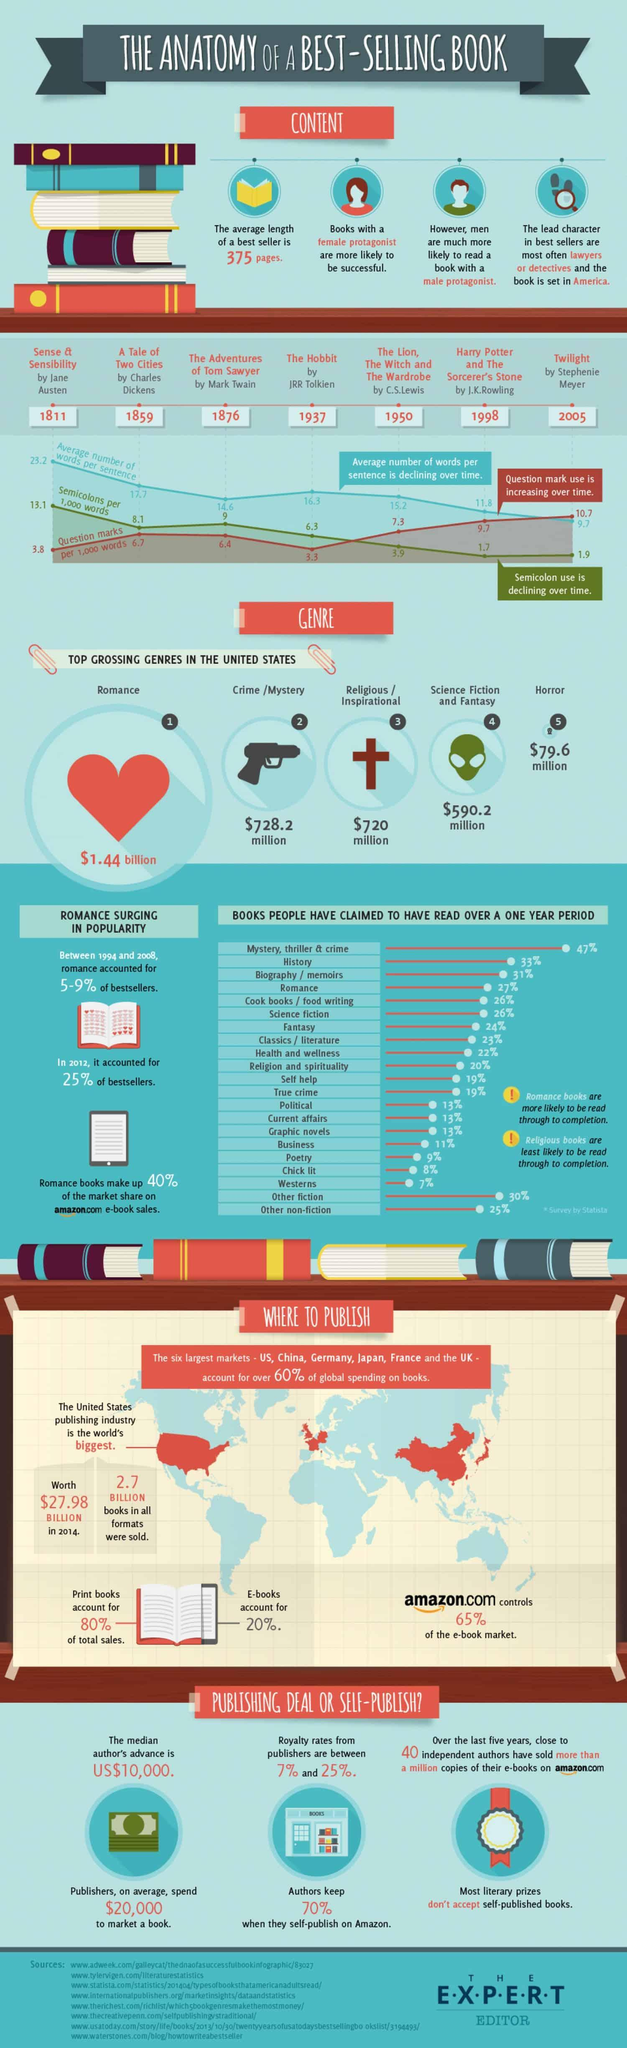Mention a couple of crucial points in this snapshot. I, [your name], declare that the author of the book "A Tale of Two Cities" is Charles Dickens. JRR Tolkien wrote "The Hobbit. Stephenie Meyer wrote the book `Twilight'. The book "The Hobbit" contains approximately 6.3 semicolons in 1000 words. The book "A Tale of Two Cities" was published in 1859. 